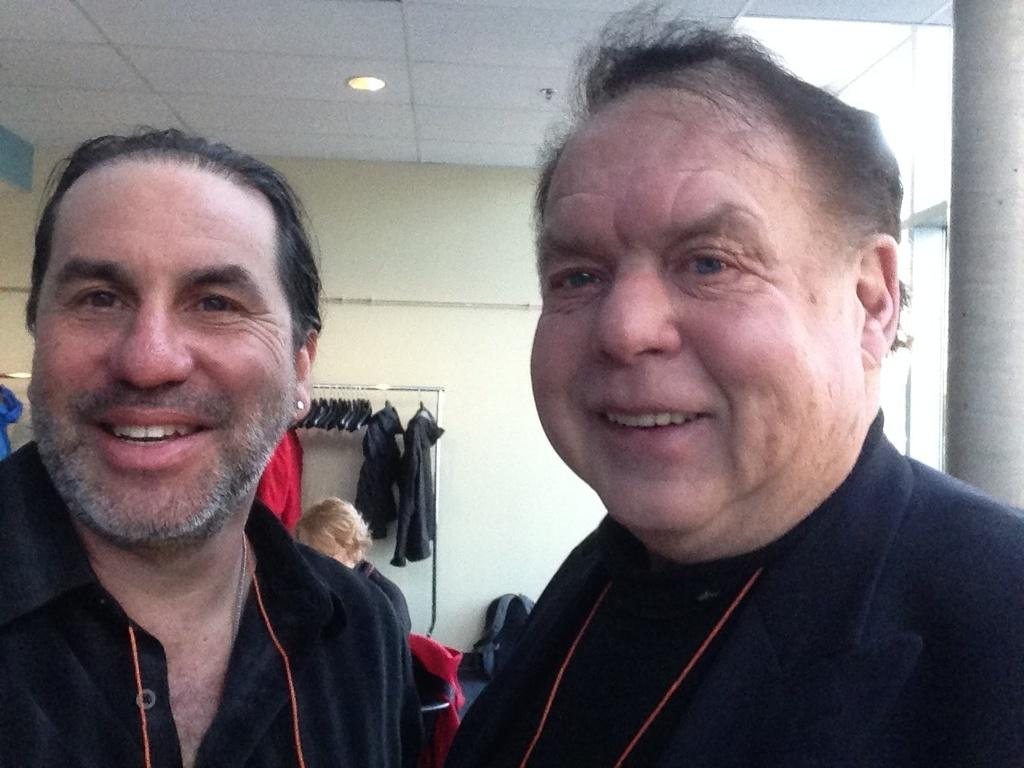How many people are present in the image? There are two men in the image. What can be seen in the background of the image? There is a wall, clothes hanging on a hanger, a woman, bags on the floor, and a light on the roof top in the background. What type of box is being used to generate profit in the image? There is no box or mention of profit in the image. 